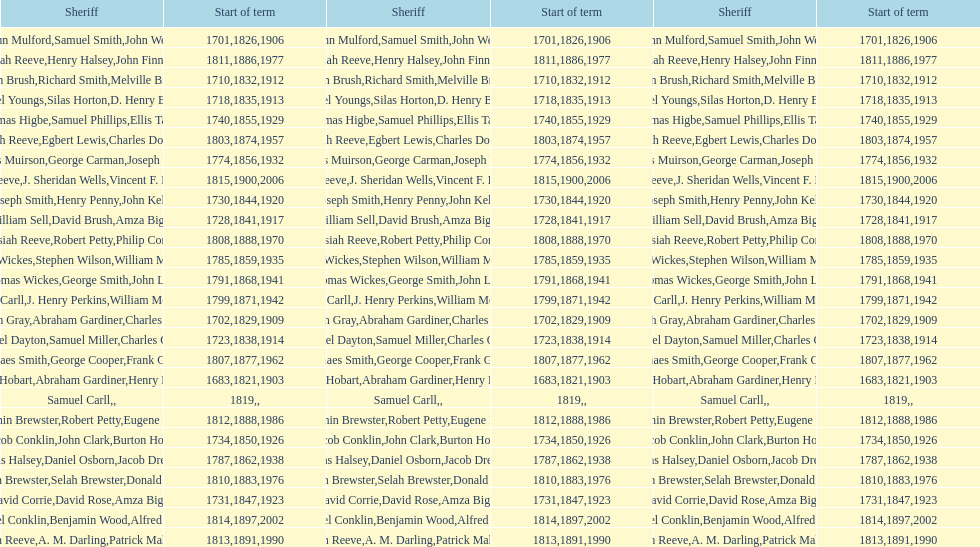When did the first sheriff's term start? 1683. 